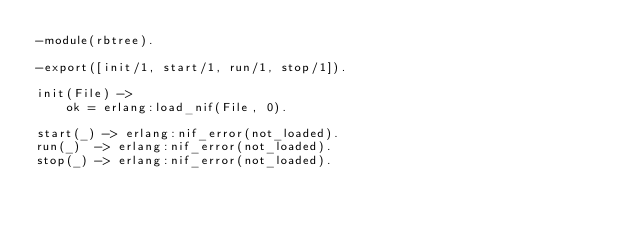Convert code to text. <code><loc_0><loc_0><loc_500><loc_500><_Erlang_>-module(rbtree).

-export([init/1, start/1, run/1, stop/1]).

init(File) ->
    ok = erlang:load_nif(File, 0).

start(_) -> erlang:nif_error(not_loaded).
run(_)  -> erlang:nif_error(not_loaded).
stop(_) -> erlang:nif_error(not_loaded).
</code> 